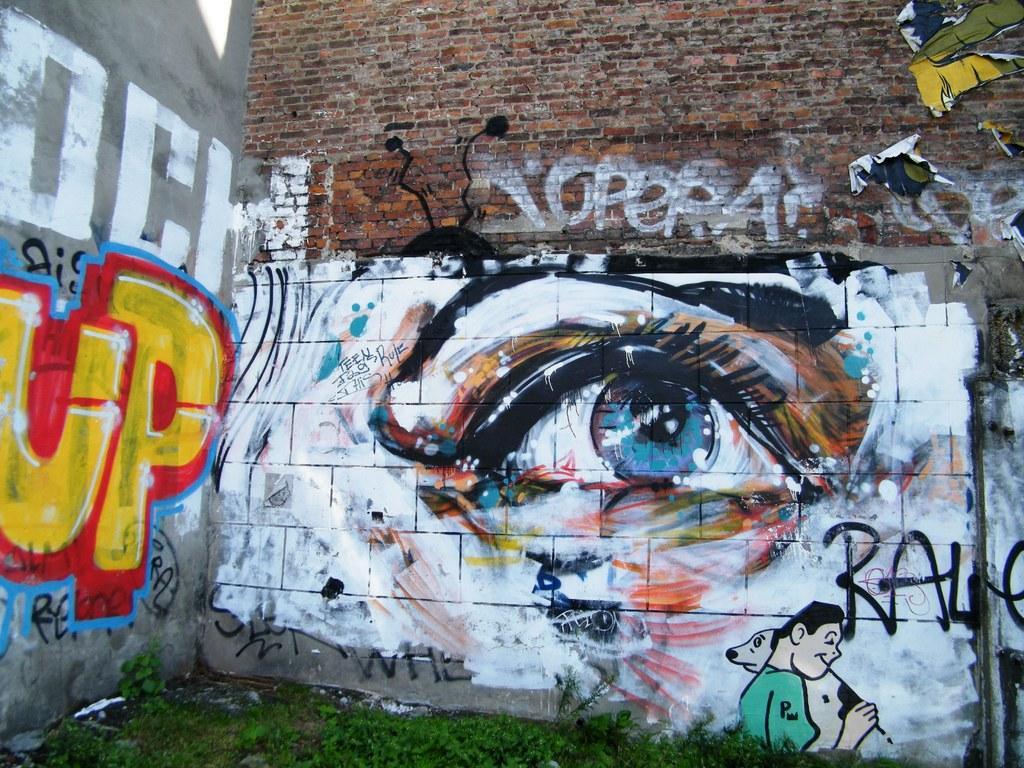In one or two sentences, can you explain what this image depicts? In this image there are walls with graffiti paints and grass in the ground. 